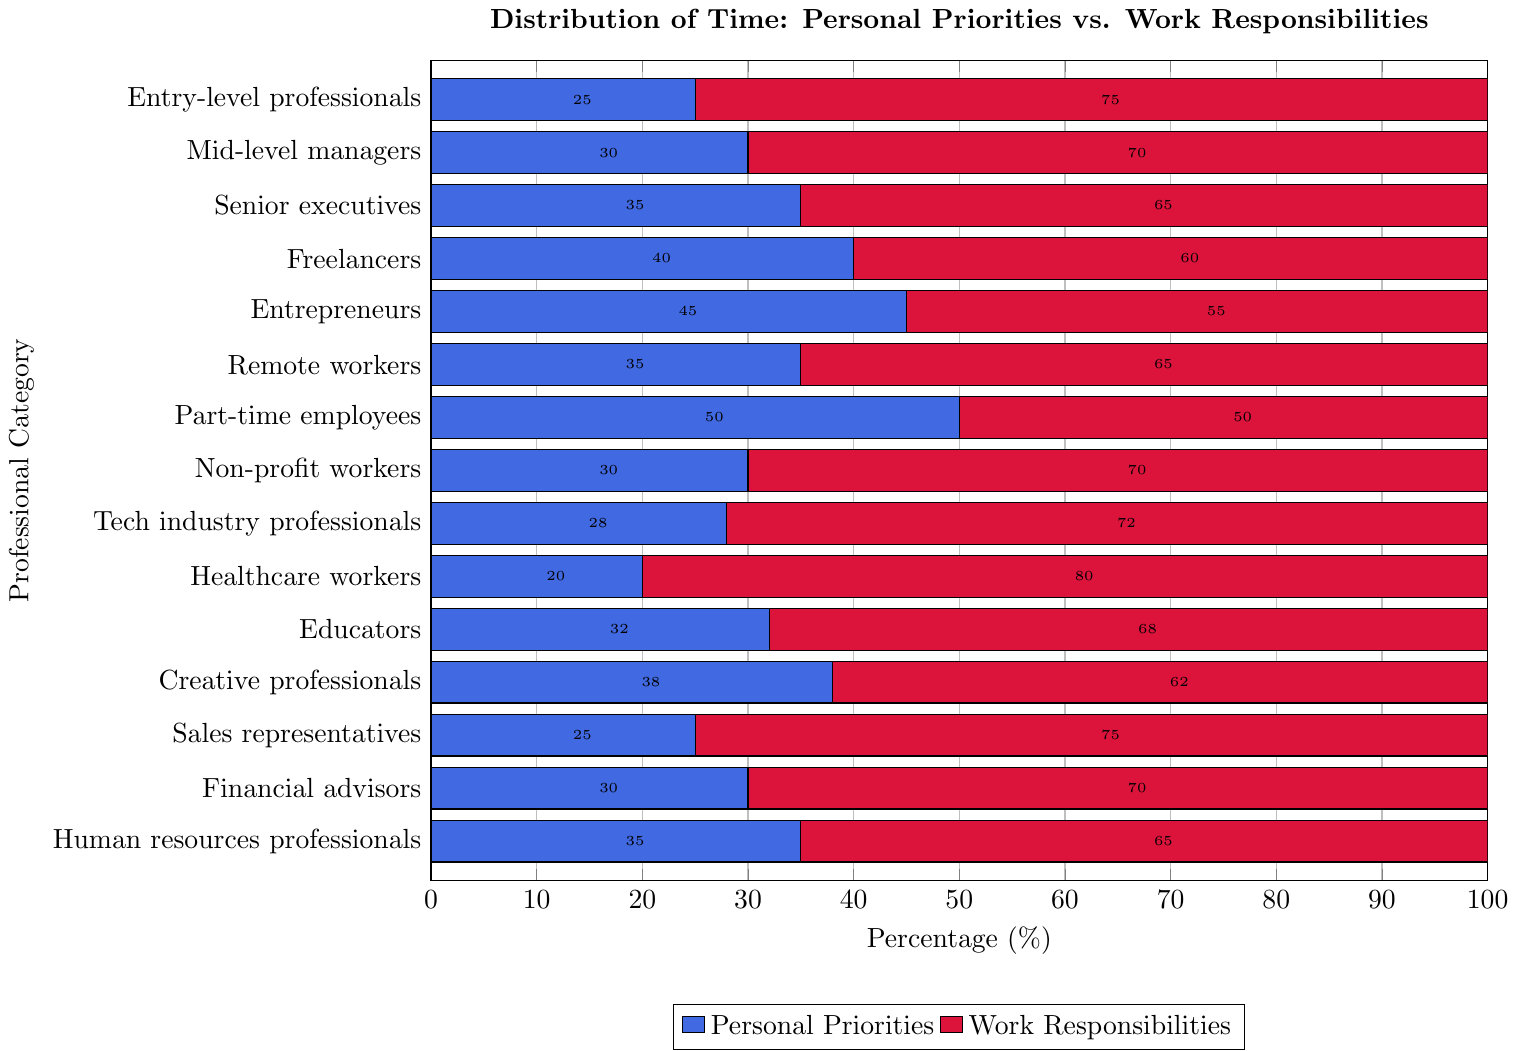What percentage of time do entry-level professionals spend on personal priorities? Look at the blue bar for entry-level professionals and read the value from the x-axis, which is 25%.
Answer: 25% Which professional category spends the least amount of time on personal priorities? Identify the smallest blue bar and match it to its corresponding category on the y-axis, which is healthcare workers.
Answer: Healthcare workers Compare the time freelancers and entrepreneurs spend on personal priorities. Who spends more? Compare the lengths of the blue bars for freelancers and entrepreneurs. Entrepreneurs have a longer bar at 45% compared to freelancers' 40%.
Answer: Entrepreneurs What is the difference in percentage of time spent on personal priorities between mid-level managers and senior executives? Find the blue bar values for mid-level managers (30%) and senior executives (35%). Calculate the difference: 35% - 30% = 5%.
Answer: 5% What is the combined percentage of time part-time employees spend on personal priorities and work responsibilities? Part-time employees spend 50% on personal priorities and 50% on work responsibilities. Add these percentages: 50% + 50% = 100%.
Answer: 100% Which professional category spends an equal amount of time on personal priorities and work responsibilities? Look for the category where the lengths of the blue and red bars are equal. Part-time employees spend 50% on each.
Answer: Part-time employees Calculate the average percentage of time spent on personal priorities across all categories. Add up all the percentages of time spent on personal priorities: 25 + 30 + 35 + 40 + 45 + 35 + 50 + 30 + 28 + 20 + 32 + 38 + 25 + 30 + 35 = 498. Divide by the number of categories (15): 498 / 15 ≈ 33.2%.
Answer: 33.2% Among tech industry professionals and educators, who has a higher percentage of time allocated to work responsibilities? Compare the red bars for both categories. Tech industry professionals spend 72% on work responsibilities, and educators spend 68%. So, tech industry professionals spend more.
Answer: Tech industry professionals What is the median percentage of time spent on personal priorities? List all values of time spent on personal priorities: 20, 25, 25, 28, 30, 30, 30, 32, 35, 35, 35, 38, 40, 45, 50. The median is the 8th value in the ordered list, which is 32%.
Answer: 32% How much more time do creative professionals spend on personal priorities compared to sales representatives? Identify the blue bars for creative professionals (38%) and sales representatives (25%), then subtract: 38% - 25% = 13%.
Answer: 13% 